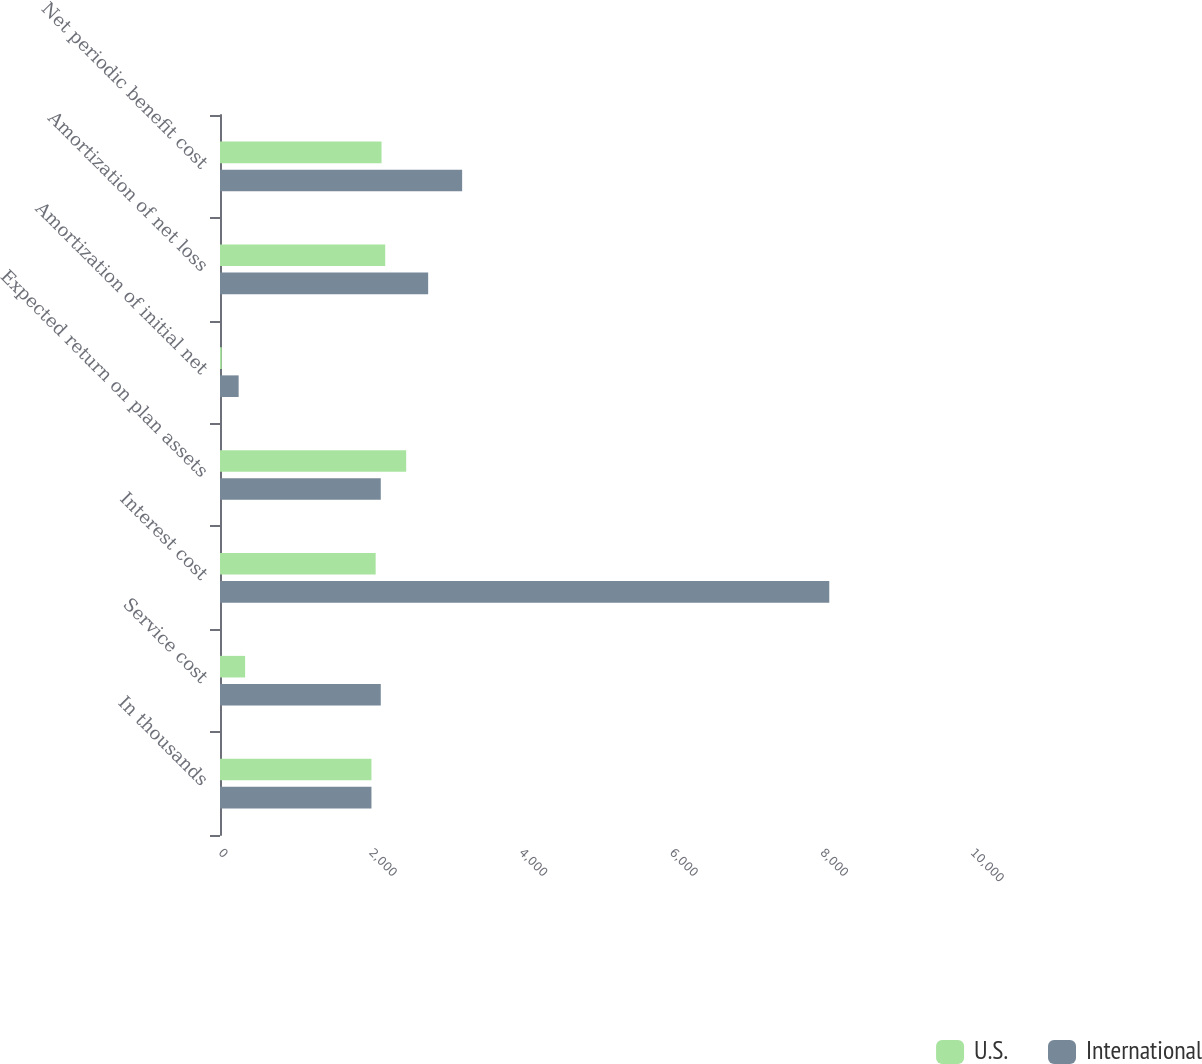Convert chart. <chart><loc_0><loc_0><loc_500><loc_500><stacked_bar_chart><ecel><fcel>In thousands<fcel>Service cost<fcel>Interest cost<fcel>Expected return on plan assets<fcel>Amortization of initial net<fcel>Amortization of net loss<fcel>Net periodic benefit cost<nl><fcel>U.S.<fcel>2014<fcel>334<fcel>2070<fcel>2476<fcel>23<fcel>2197<fcel>2148<nl><fcel>International<fcel>2014<fcel>2138<fcel>8102<fcel>2138<fcel>248<fcel>2768<fcel>3220<nl></chart> 